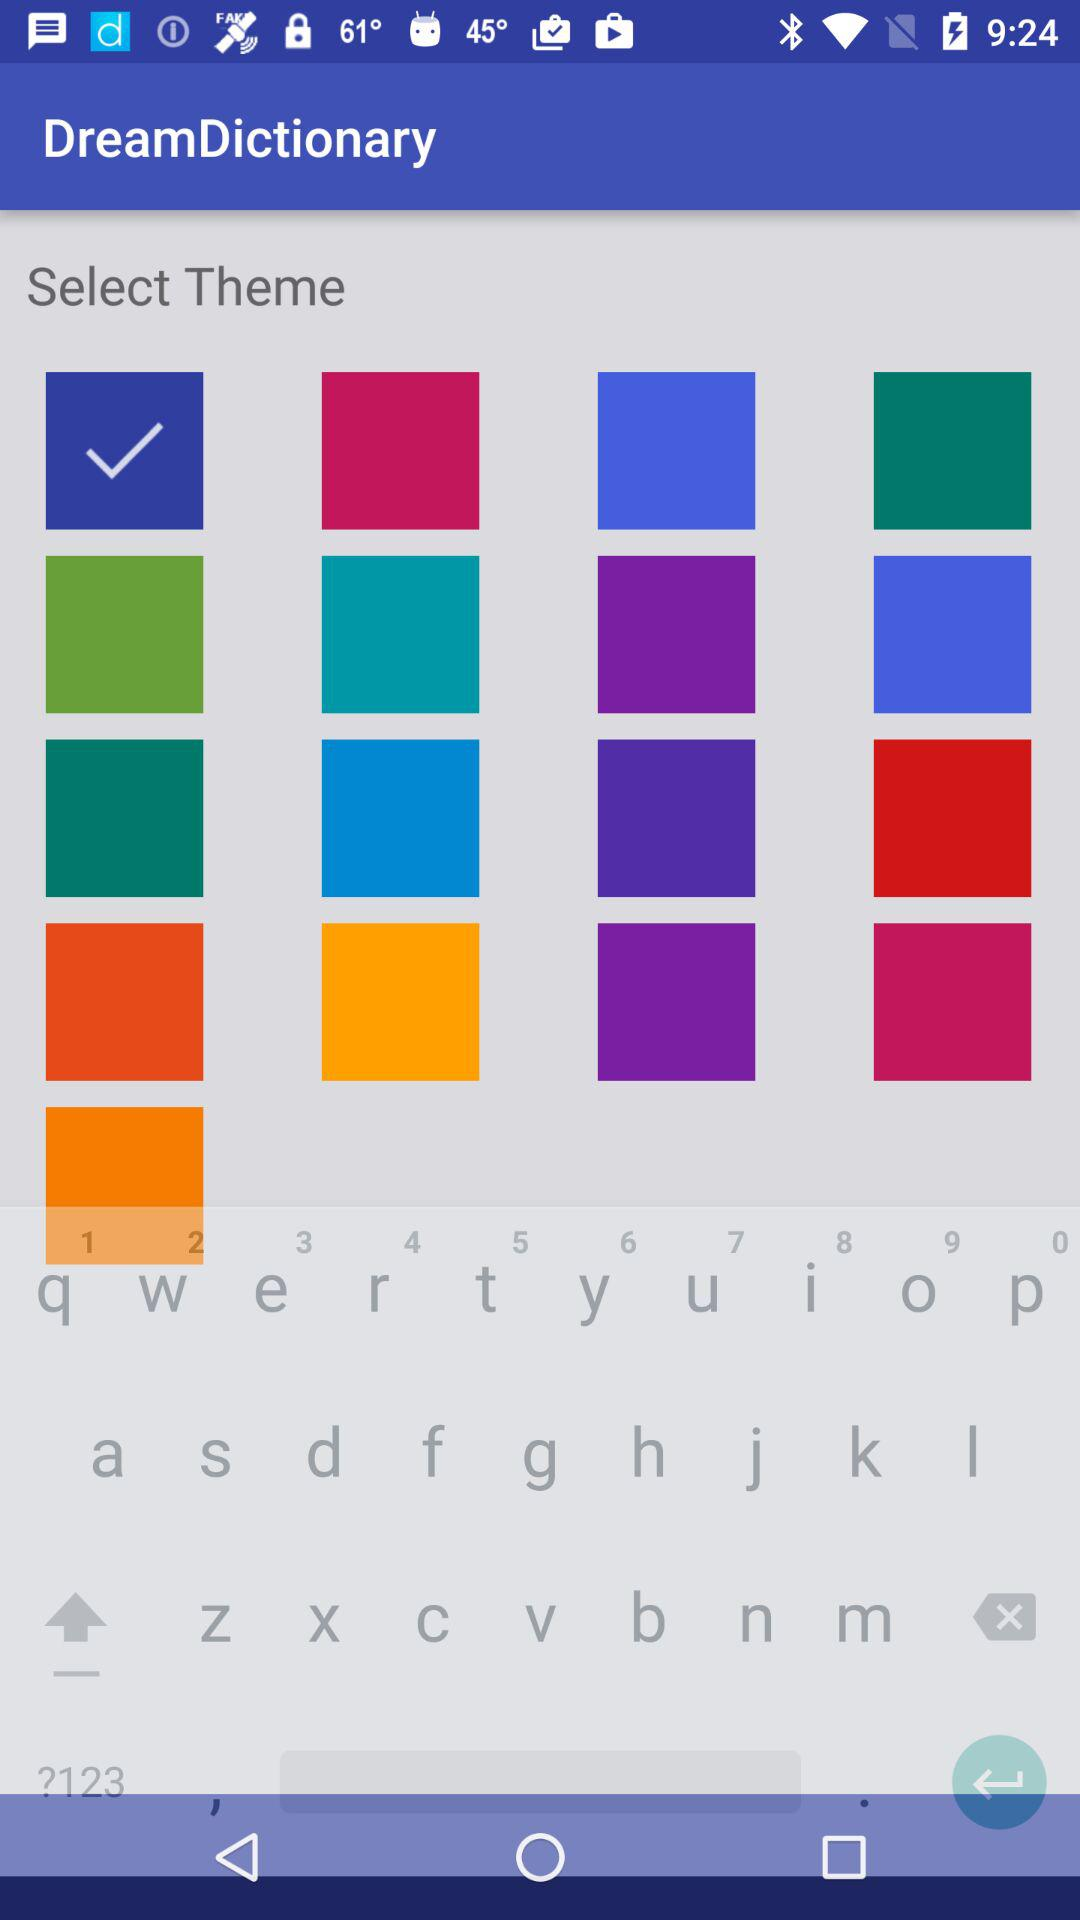How many squares are in the top row?
Answer the question using a single word or phrase. 4 